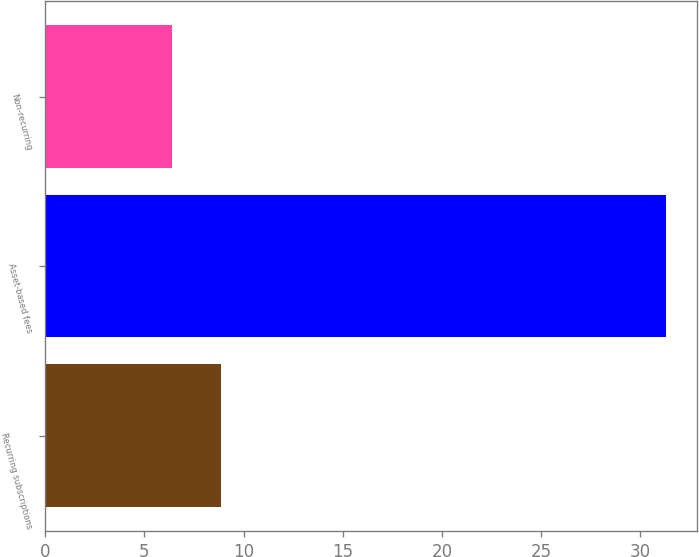Convert chart. <chart><loc_0><loc_0><loc_500><loc_500><bar_chart><fcel>Recurring subscriptions<fcel>Asset-based fees<fcel>Non-recurring<nl><fcel>8.89<fcel>31.3<fcel>6.4<nl></chart> 